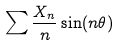Convert formula to latex. <formula><loc_0><loc_0><loc_500><loc_500>\sum \frac { X _ { n } } { n } \sin ( n \theta )</formula> 